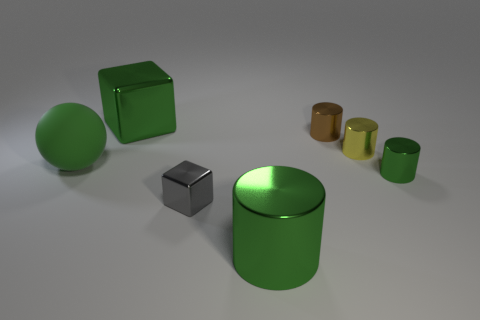The big sphere is what color?
Provide a short and direct response. Green. There is a small cylinder that is in front of the large matte sphere; is it the same color as the matte ball?
Offer a very short reply. Yes. What material is the large cube that is the same color as the large matte object?
Ensure brevity in your answer.  Metal. How many big metal objects are the same color as the rubber object?
Offer a very short reply. 2. Is the shape of the big green metal thing that is behind the large cylinder the same as  the yellow thing?
Give a very brief answer. No. Are there fewer small yellow objects that are in front of the big metallic cylinder than brown cylinders left of the big ball?
Provide a succinct answer. No. There is a green cylinder that is behind the tiny cube; what material is it?
Ensure brevity in your answer.  Metal. What size is the other metal cylinder that is the same color as the large cylinder?
Provide a short and direct response. Small. Are there any gray cubes that have the same size as the matte thing?
Provide a short and direct response. No. Do the tiny gray thing and the object that is left of the big green block have the same shape?
Your answer should be compact. No. 